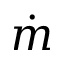<formula> <loc_0><loc_0><loc_500><loc_500>\dot { m }</formula> 